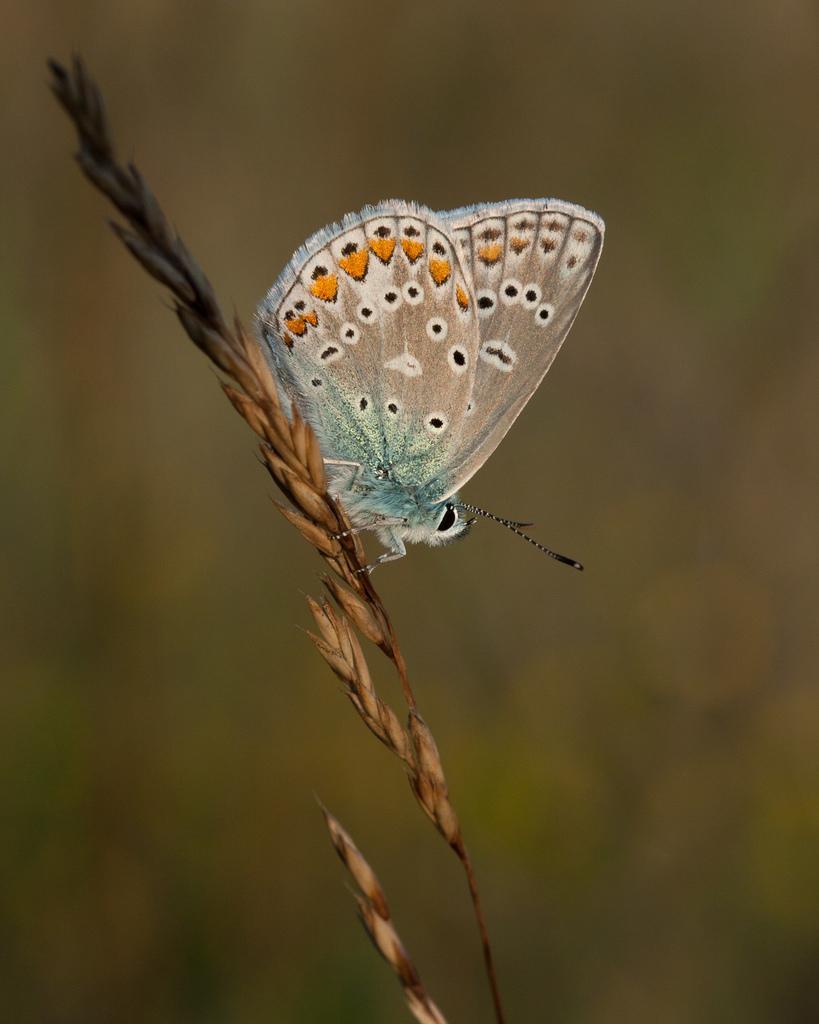Could you give a brief overview of what you see in this image? Here I can see a straw with grains. On this there is a butterfly. The background is blurred. 